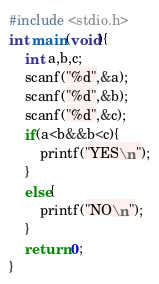Convert code to text. <code><loc_0><loc_0><loc_500><loc_500><_C_>#include <stdio.h>
int main(void){
    int a,b,c;
    scanf("%d",&a);
    scanf("%d",&b);
    scanf("%d",&c);
    if(a<b&&b<c){
        printf("YES\n");
    }
    else{
        printf("NO\n");
    }
    return 0;
}
</code> 